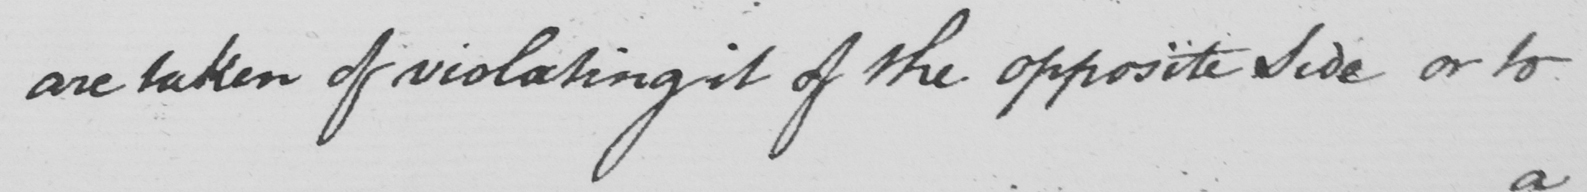Can you read and transcribe this handwriting? are taken of violating it of the opposite side or to 